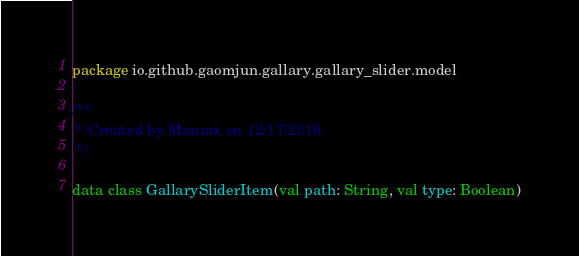<code> <loc_0><loc_0><loc_500><loc_500><_Kotlin_>package io.github.gaomjun.gallary.gallary_slider.model

/**
 * Created by Mannix on 12/17/2016.
 */

data class GallarySliderItem(val path: String, val type: Boolean)</code> 